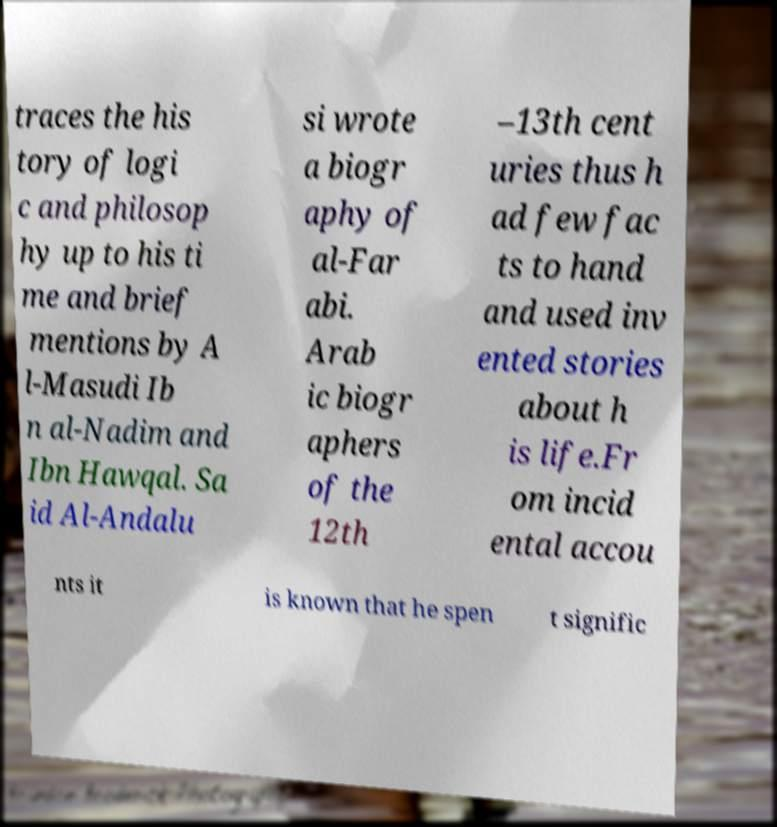Could you extract and type out the text from this image? traces the his tory of logi c and philosop hy up to his ti me and brief mentions by A l-Masudi Ib n al-Nadim and Ibn Hawqal. Sa id Al-Andalu si wrote a biogr aphy of al-Far abi. Arab ic biogr aphers of the 12th –13th cent uries thus h ad few fac ts to hand and used inv ented stories about h is life.Fr om incid ental accou nts it is known that he spen t signific 